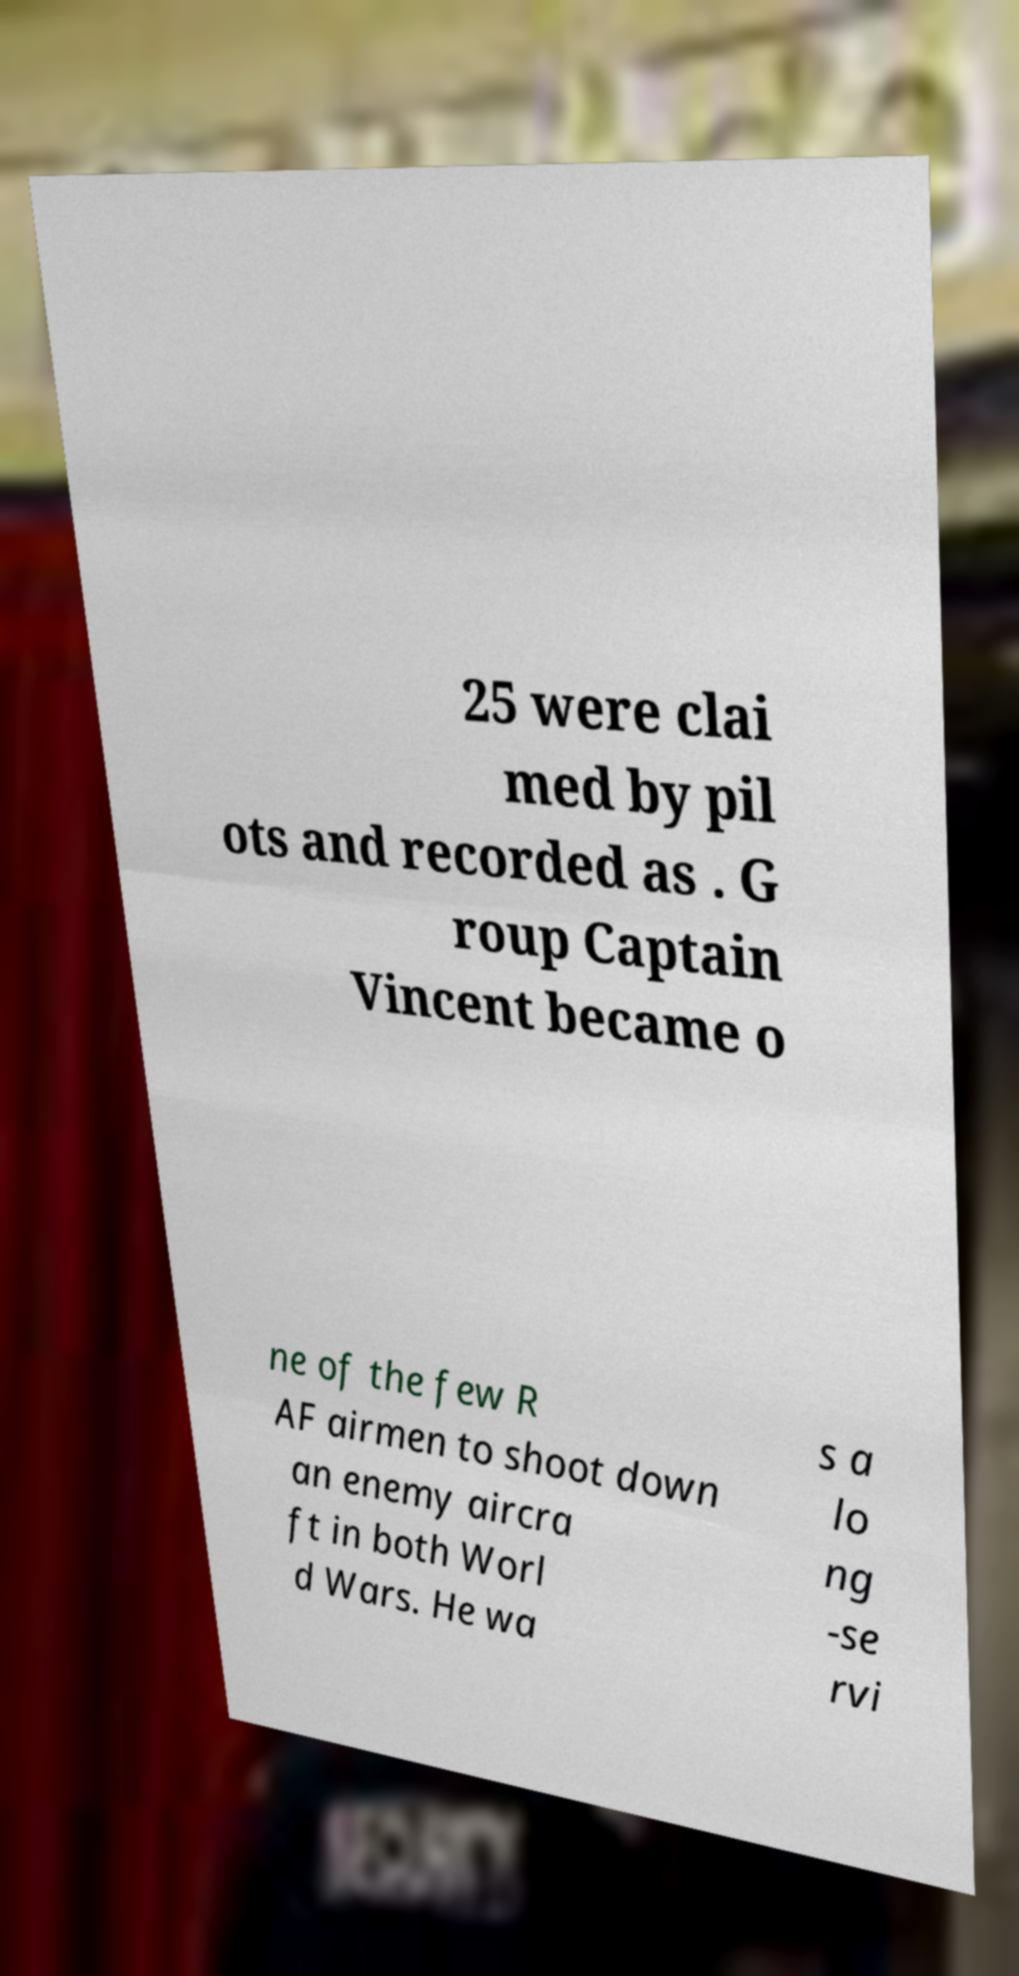What messages or text are displayed in this image? I need them in a readable, typed format. 25 were clai med by pil ots and recorded as . G roup Captain Vincent became o ne of the few R AF airmen to shoot down an enemy aircra ft in both Worl d Wars. He wa s a lo ng -se rvi 